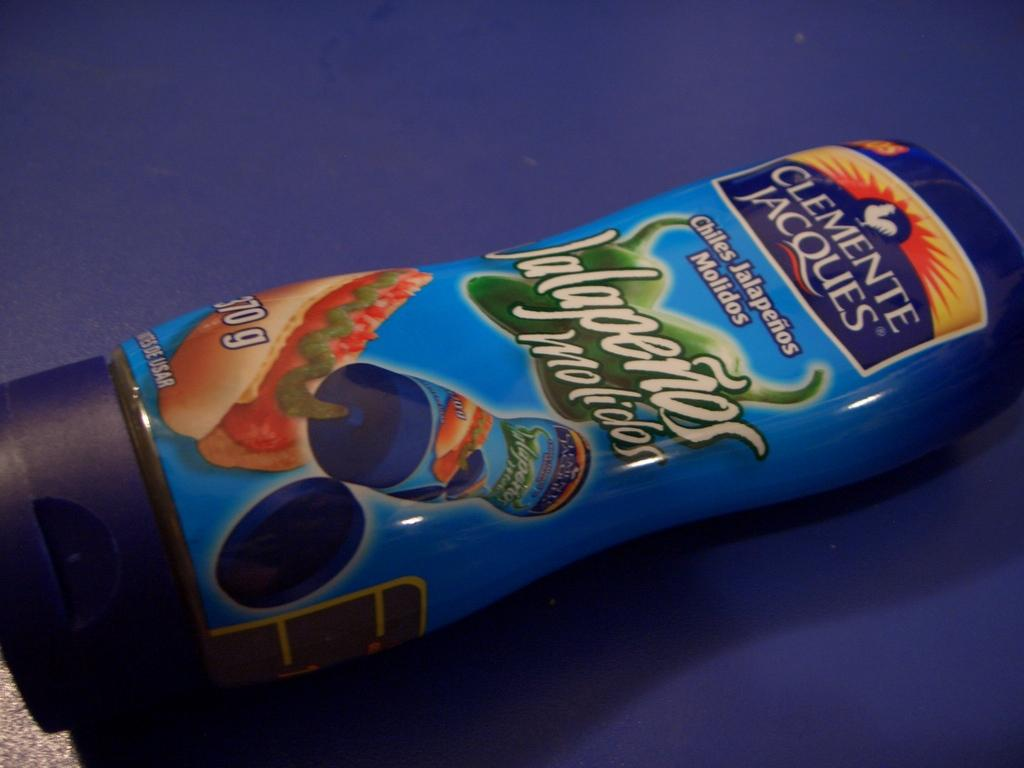<image>
Write a terse but informative summary of the picture. A blue container of Jalapenos sauce made by Clemente Jacques. 